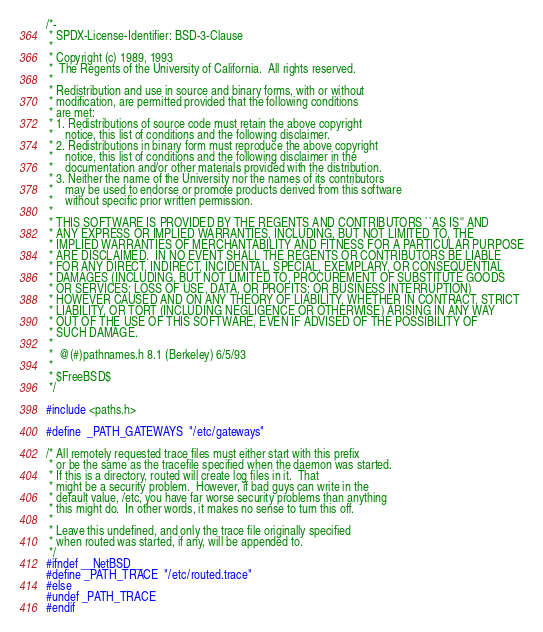<code> <loc_0><loc_0><loc_500><loc_500><_C_>/*-
 * SPDX-License-Identifier: BSD-3-Clause
 *
 * Copyright (c) 1989, 1993
 *	The Regents of the University of California.  All rights reserved.
 *
 * Redistribution and use in source and binary forms, with or without
 * modification, are permitted provided that the following conditions
 * are met:
 * 1. Redistributions of source code must retain the above copyright
 *    notice, this list of conditions and the following disclaimer.
 * 2. Redistributions in binary form must reproduce the above copyright
 *    notice, this list of conditions and the following disclaimer in the
 *    documentation and/or other materials provided with the distribution.
 * 3. Neither the name of the University nor the names of its contributors
 *    may be used to endorse or promote products derived from this software
 *    without specific prior written permission.
 *
 * THIS SOFTWARE IS PROVIDED BY THE REGENTS AND CONTRIBUTORS ``AS IS'' AND
 * ANY EXPRESS OR IMPLIED WARRANTIES, INCLUDING, BUT NOT LIMITED TO, THE
 * IMPLIED WARRANTIES OF MERCHANTABILITY AND FITNESS FOR A PARTICULAR PURPOSE
 * ARE DISCLAIMED.  IN NO EVENT SHALL THE REGENTS OR CONTRIBUTORS BE LIABLE
 * FOR ANY DIRECT, INDIRECT, INCIDENTAL, SPECIAL, EXEMPLARY, OR CONSEQUENTIAL
 * DAMAGES (INCLUDING, BUT NOT LIMITED TO, PROCUREMENT OF SUBSTITUTE GOODS
 * OR SERVICES; LOSS OF USE, DATA, OR PROFITS; OR BUSINESS INTERRUPTION)
 * HOWEVER CAUSED AND ON ANY THEORY OF LIABILITY, WHETHER IN CONTRACT, STRICT
 * LIABILITY, OR TORT (INCLUDING NEGLIGENCE OR OTHERWISE) ARISING IN ANY WAY
 * OUT OF THE USE OF THIS SOFTWARE, EVEN IF ADVISED OF THE POSSIBILITY OF
 * SUCH DAMAGE.
 *
 *	@(#)pathnames.h	8.1 (Berkeley) 6/5/93
 *
 * $FreeBSD$
 */

#include <paths.h>

#define	_PATH_GATEWAYS	"/etc/gateways"

/* All remotely requested trace files must either start with this prefix
 * or be the same as the tracefile specified when the daemon was started.
 * If this is a directory, routed will create log files in it.  That
 * might be a security problem.  However, if bad guys can write in the
 * default value, /etc, you have far worse security problems than anything
 * this might do.  In other words, it makes no sense to turn this off.
 *
 * Leave this undefined, and only the trace file originally specified
 * when routed was started, if any, will be appended to.
 */
#ifndef __NetBSD__
#define _PATH_TRACE	"/etc/routed.trace"
#else
#undef _PATH_TRACE
#endif
</code> 